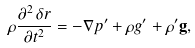<formula> <loc_0><loc_0><loc_500><loc_500>\rho \frac { \partial ^ { 2 } \, \delta r } { \partial t ^ { 2 } } = - \nabla p ^ { \prime } + \rho g ^ { \prime } + \rho ^ { \prime } { \mathbf g } ,</formula> 